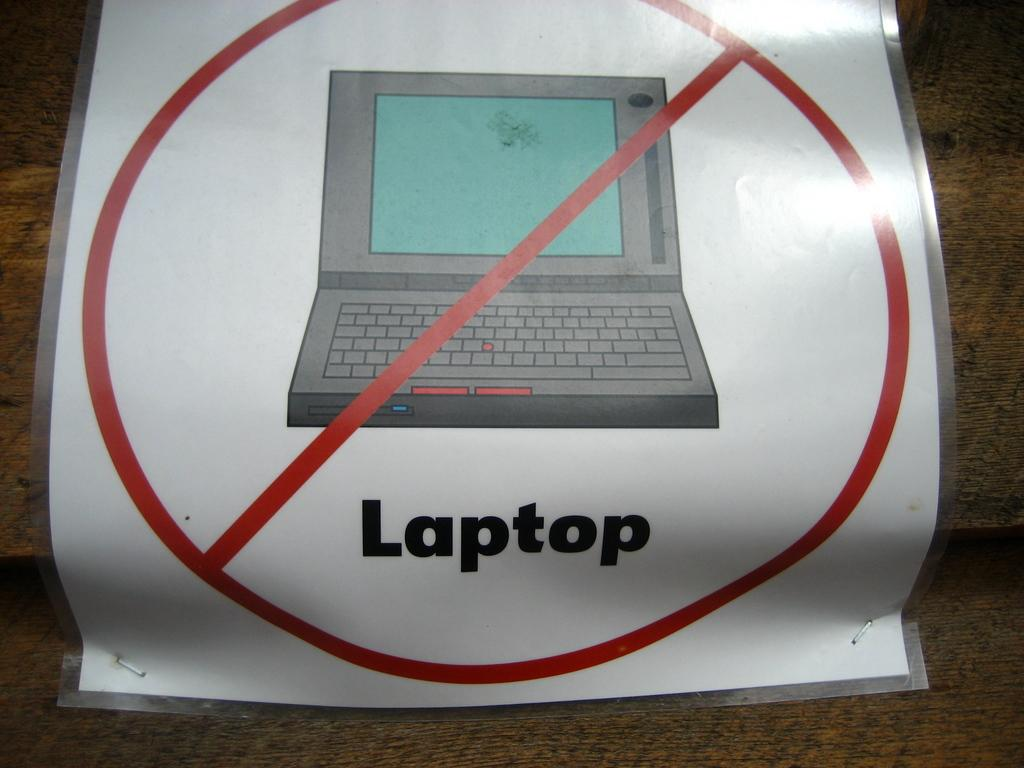What type of paper is visible in the image? There is a laminated paper in the image. What is depicted on the laminated paper? The laminated paper has an image of a laptop on it. Are there any words or phrases written on the laminated paper? Yes, there is text written on the laminated paper. What is the main piece of furniture in the image? There is a table at the bottom of the image. What type of song can be heard playing in the background of the image? There is no song or audio present in the image; it is a still image of a laminated paper with a laptop image and text. Are there any mittens visible in the image? No, there are no mittens present in the image. 